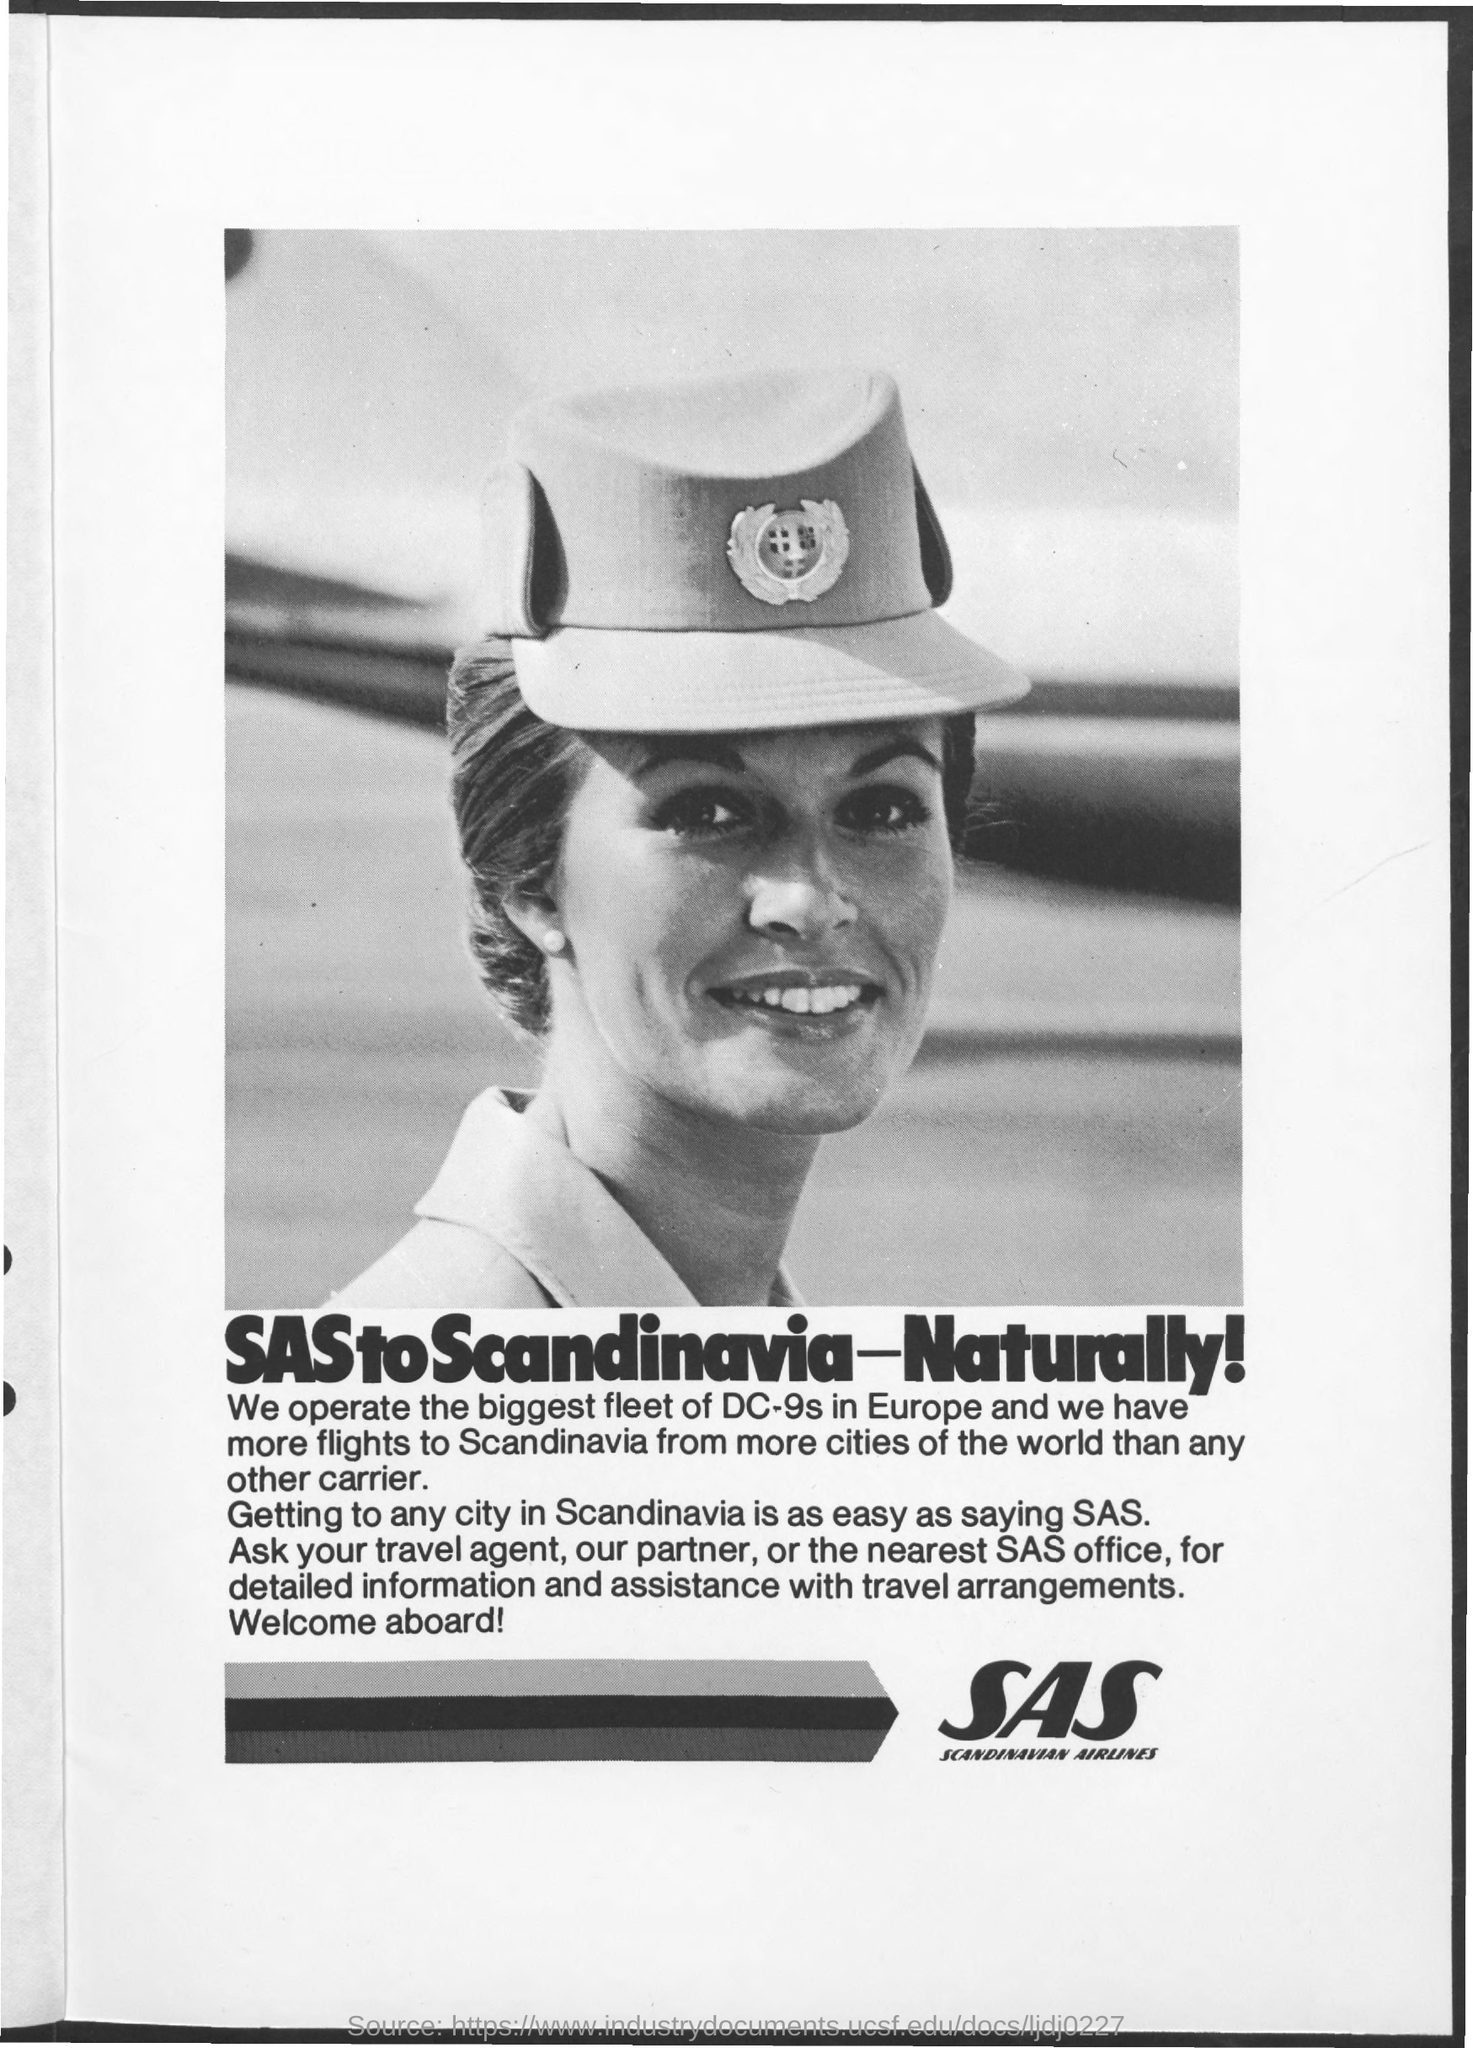What is SAS ?
Give a very brief answer. SCANDINAVIAN AIRLINES. Which office should be approached for the detailed information and assistance with travel arrangements?
Make the answer very short. Sas office. 